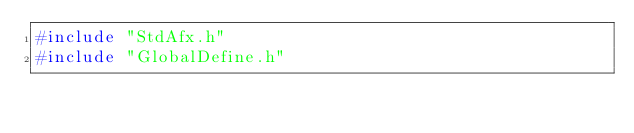<code> <loc_0><loc_0><loc_500><loc_500><_C++_>#include "StdAfx.h"
#include "GlobalDefine.h"
</code> 